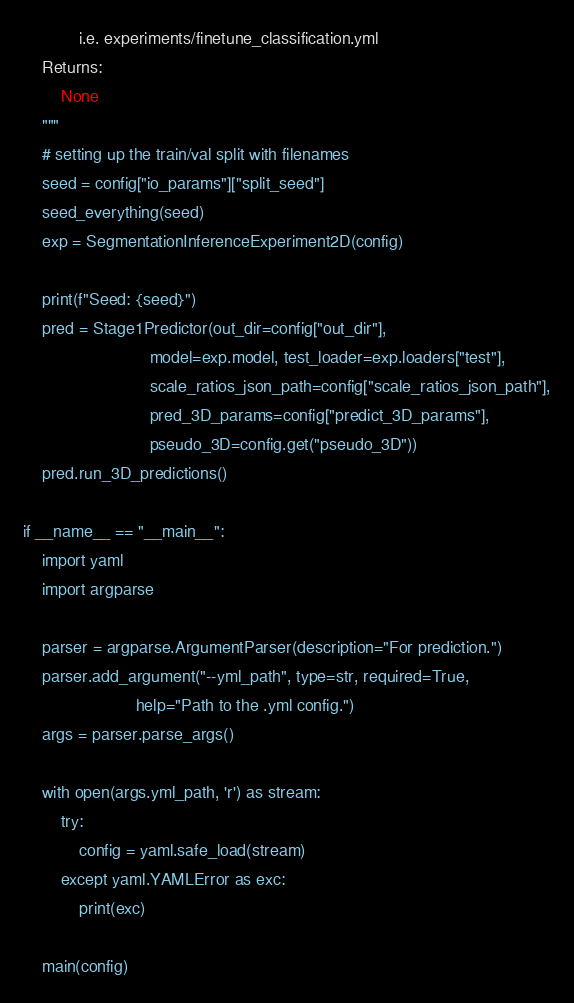Convert code to text. <code><loc_0><loc_0><loc_500><loc_500><_Python_>            i.e. experiments/finetune_classification.yml
    Returns:
        None
    """
    # setting up the train/val split with filenames
    seed = config["io_params"]["split_seed"]
    seed_everything(seed)
    exp = SegmentationInferenceExperiment2D(config)

    print(f"Seed: {seed}")
    pred = Stage1Predictor(out_dir=config["out_dir"],
                           model=exp.model, test_loader=exp.loaders["test"],
                           scale_ratios_json_path=config["scale_ratios_json_path"],
                           pred_3D_params=config["predict_3D_params"],
                           pseudo_3D=config.get("pseudo_3D"))
    pred.run_3D_predictions()

if __name__ == "__main__":
    import yaml
    import argparse

    parser = argparse.ArgumentParser(description="For prediction.")
    parser.add_argument("--yml_path", type=str, required=True,
                        help="Path to the .yml config.")
    args = parser.parse_args()

    with open(args.yml_path, 'r') as stream:
        try:
            config = yaml.safe_load(stream)
        except yaml.YAMLError as exc:
            print(exc)

    main(config)
</code> 